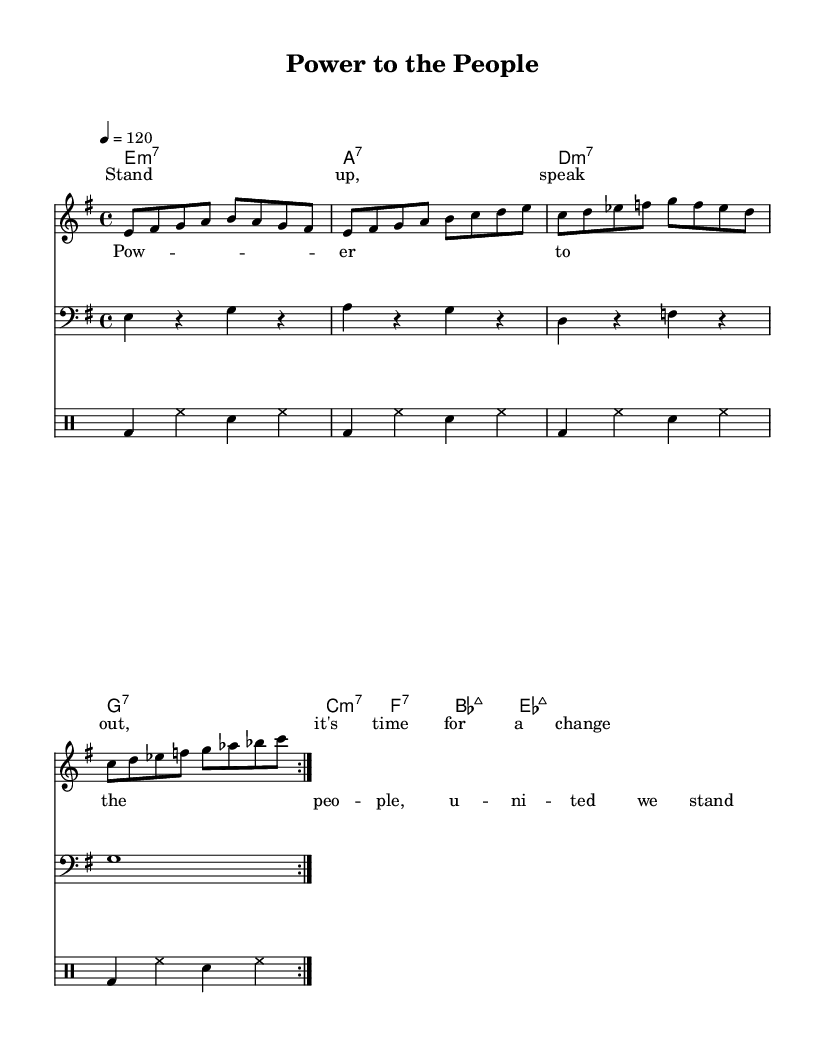What is the key signature of this music? The key signature is listed on the left side of the staff line, and it shows one sharp, indicating the E minor scale.
Answer: E minor What is the time signature of this music? The time signature appears at the beginning of the staff, shown by the two numbers, where the top number indicates 4 beats per measure and the bottom number indicates that a quarter note receives one beat.
Answer: 4/4 What is the tempo marking of this music? The tempo marking is noted in beats per minute, which shows that the tempo is set at 120 beats per minute.
Answer: 120 How many measures are there in the melody section? By counting the number of bars in the melody line, there are a total of 8 measures in the repeated section.
Answer: 8 What chord is played on the first measure? The chord indicated at the start of the score is in the chord names section, showing an E minor 7 chord that appears on the first measure.
Answer: E minor 7 Which lyrical phrase repeats in the chorus section? The repeated phrase "Power to the people" can be found in the lyrics of the chorus as indicated in distinct lines.
Answer: Power to the people What is the rhythm pattern played by the drums? The drumming pattern is consistent in all measures, where it features a bass drum on the first beat, followed by hi-hat and snare in a steady groove, capturing the funk rhythm.
Answer: Bass drum, hi-hat, snare 